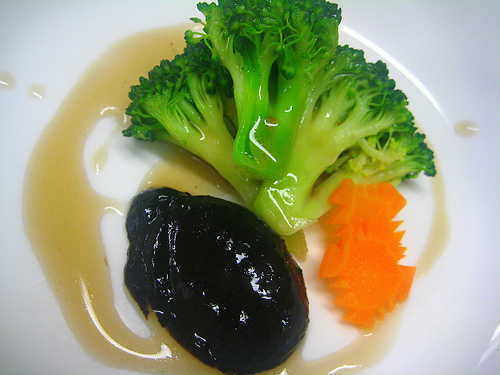What do you think is the color of the dish? The dish itself appears to be off-white with a glossy finish, providing a neutral background that contrasts with the colors of the food presented on it. 